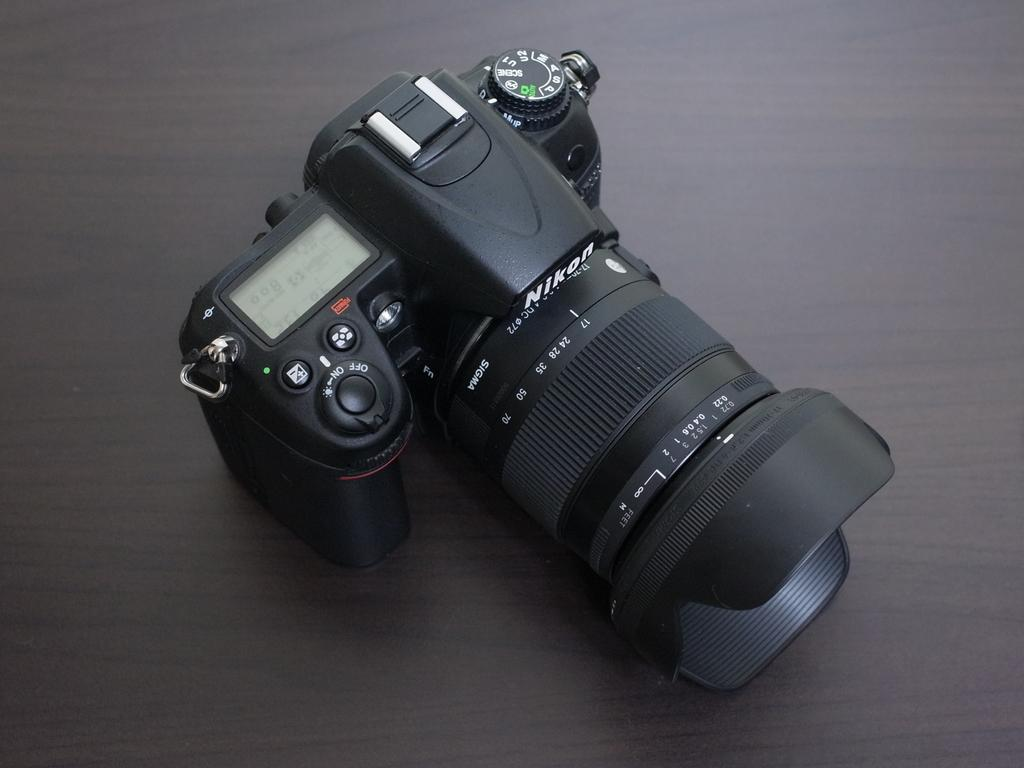<image>
Create a compact narrative representing the image presented. A Nikon brand camera is on a brown surface. 